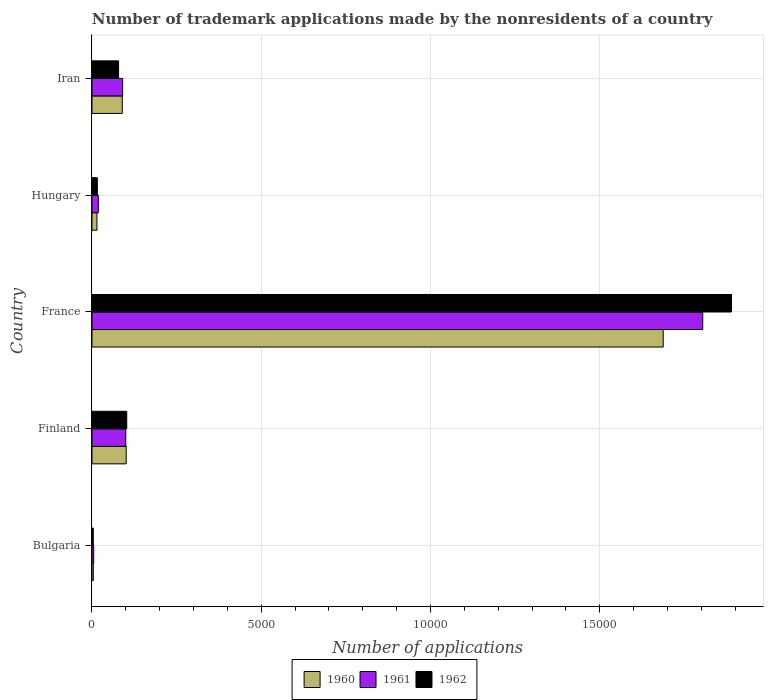How many different coloured bars are there?
Provide a succinct answer. 3. What is the label of the 1st group of bars from the top?
Ensure brevity in your answer.  Iran. In how many cases, is the number of bars for a given country not equal to the number of legend labels?
Give a very brief answer. 0. What is the number of trademark applications made by the nonresidents in 1961 in Finland?
Make the answer very short. 998. Across all countries, what is the maximum number of trademark applications made by the nonresidents in 1962?
Offer a very short reply. 1.89e+04. In which country was the number of trademark applications made by the nonresidents in 1960 maximum?
Make the answer very short. France. What is the total number of trademark applications made by the nonresidents in 1960 in the graph?
Your response must be concise. 1.90e+04. What is the difference between the number of trademark applications made by the nonresidents in 1960 in Hungary and that in Iran?
Your response must be concise. -748. What is the difference between the number of trademark applications made by the nonresidents in 1961 in Bulgaria and the number of trademark applications made by the nonresidents in 1960 in Iran?
Give a very brief answer. -844. What is the average number of trademark applications made by the nonresidents in 1962 per country?
Keep it short and to the point. 4180.2. What is the difference between the number of trademark applications made by the nonresidents in 1961 and number of trademark applications made by the nonresidents in 1960 in France?
Give a very brief answer. 1168. In how many countries, is the number of trademark applications made by the nonresidents in 1962 greater than 13000 ?
Give a very brief answer. 1. What is the ratio of the number of trademark applications made by the nonresidents in 1961 in Bulgaria to that in France?
Provide a succinct answer. 0. Is the difference between the number of trademark applications made by the nonresidents in 1961 in France and Hungary greater than the difference between the number of trademark applications made by the nonresidents in 1960 in France and Hungary?
Offer a very short reply. Yes. What is the difference between the highest and the second highest number of trademark applications made by the nonresidents in 1962?
Offer a very short reply. 1.79e+04. What is the difference between the highest and the lowest number of trademark applications made by the nonresidents in 1962?
Keep it short and to the point. 1.89e+04. Is the sum of the number of trademark applications made by the nonresidents in 1960 in Bulgaria and Iran greater than the maximum number of trademark applications made by the nonresidents in 1962 across all countries?
Make the answer very short. No. How many bars are there?
Give a very brief answer. 15. Are the values on the major ticks of X-axis written in scientific E-notation?
Give a very brief answer. No. Where does the legend appear in the graph?
Provide a short and direct response. Bottom center. How are the legend labels stacked?
Provide a short and direct response. Horizontal. What is the title of the graph?
Ensure brevity in your answer.  Number of trademark applications made by the nonresidents of a country. What is the label or title of the X-axis?
Keep it short and to the point. Number of applications. What is the label or title of the Y-axis?
Offer a terse response. Country. What is the Number of applications of 1961 in Bulgaria?
Offer a terse response. 51. What is the Number of applications in 1962 in Bulgaria?
Your answer should be compact. 38. What is the Number of applications of 1960 in Finland?
Your answer should be very brief. 1011. What is the Number of applications in 1961 in Finland?
Ensure brevity in your answer.  998. What is the Number of applications of 1962 in Finland?
Ensure brevity in your answer.  1027. What is the Number of applications of 1960 in France?
Make the answer very short. 1.69e+04. What is the Number of applications in 1961 in France?
Your answer should be compact. 1.80e+04. What is the Number of applications of 1962 in France?
Give a very brief answer. 1.89e+04. What is the Number of applications in 1960 in Hungary?
Make the answer very short. 147. What is the Number of applications in 1961 in Hungary?
Your answer should be compact. 188. What is the Number of applications of 1962 in Hungary?
Provide a succinct answer. 158. What is the Number of applications in 1960 in Iran?
Ensure brevity in your answer.  895. What is the Number of applications of 1961 in Iran?
Give a very brief answer. 905. What is the Number of applications in 1962 in Iran?
Provide a succinct answer. 786. Across all countries, what is the maximum Number of applications of 1960?
Your response must be concise. 1.69e+04. Across all countries, what is the maximum Number of applications of 1961?
Your answer should be very brief. 1.80e+04. Across all countries, what is the maximum Number of applications of 1962?
Make the answer very short. 1.89e+04. Across all countries, what is the minimum Number of applications of 1960?
Your answer should be compact. 39. Across all countries, what is the minimum Number of applications of 1962?
Provide a short and direct response. 38. What is the total Number of applications in 1960 in the graph?
Offer a terse response. 1.90e+04. What is the total Number of applications of 1961 in the graph?
Your answer should be compact. 2.02e+04. What is the total Number of applications of 1962 in the graph?
Offer a terse response. 2.09e+04. What is the difference between the Number of applications in 1960 in Bulgaria and that in Finland?
Your answer should be compact. -972. What is the difference between the Number of applications in 1961 in Bulgaria and that in Finland?
Ensure brevity in your answer.  -947. What is the difference between the Number of applications in 1962 in Bulgaria and that in Finland?
Keep it short and to the point. -989. What is the difference between the Number of applications of 1960 in Bulgaria and that in France?
Provide a succinct answer. -1.68e+04. What is the difference between the Number of applications of 1961 in Bulgaria and that in France?
Your response must be concise. -1.80e+04. What is the difference between the Number of applications of 1962 in Bulgaria and that in France?
Your answer should be compact. -1.89e+04. What is the difference between the Number of applications in 1960 in Bulgaria and that in Hungary?
Your response must be concise. -108. What is the difference between the Number of applications of 1961 in Bulgaria and that in Hungary?
Make the answer very short. -137. What is the difference between the Number of applications of 1962 in Bulgaria and that in Hungary?
Provide a short and direct response. -120. What is the difference between the Number of applications in 1960 in Bulgaria and that in Iran?
Give a very brief answer. -856. What is the difference between the Number of applications in 1961 in Bulgaria and that in Iran?
Your answer should be compact. -854. What is the difference between the Number of applications of 1962 in Bulgaria and that in Iran?
Offer a very short reply. -748. What is the difference between the Number of applications of 1960 in Finland and that in France?
Provide a succinct answer. -1.59e+04. What is the difference between the Number of applications in 1961 in Finland and that in France?
Offer a very short reply. -1.70e+04. What is the difference between the Number of applications of 1962 in Finland and that in France?
Keep it short and to the point. -1.79e+04. What is the difference between the Number of applications in 1960 in Finland and that in Hungary?
Make the answer very short. 864. What is the difference between the Number of applications of 1961 in Finland and that in Hungary?
Provide a succinct answer. 810. What is the difference between the Number of applications in 1962 in Finland and that in Hungary?
Ensure brevity in your answer.  869. What is the difference between the Number of applications of 1960 in Finland and that in Iran?
Ensure brevity in your answer.  116. What is the difference between the Number of applications in 1961 in Finland and that in Iran?
Provide a short and direct response. 93. What is the difference between the Number of applications in 1962 in Finland and that in Iran?
Offer a terse response. 241. What is the difference between the Number of applications in 1960 in France and that in Hungary?
Offer a very short reply. 1.67e+04. What is the difference between the Number of applications of 1961 in France and that in Hungary?
Provide a succinct answer. 1.79e+04. What is the difference between the Number of applications of 1962 in France and that in Hungary?
Your answer should be compact. 1.87e+04. What is the difference between the Number of applications in 1960 in France and that in Iran?
Ensure brevity in your answer.  1.60e+04. What is the difference between the Number of applications of 1961 in France and that in Iran?
Your answer should be compact. 1.71e+04. What is the difference between the Number of applications in 1962 in France and that in Iran?
Make the answer very short. 1.81e+04. What is the difference between the Number of applications in 1960 in Hungary and that in Iran?
Give a very brief answer. -748. What is the difference between the Number of applications of 1961 in Hungary and that in Iran?
Provide a short and direct response. -717. What is the difference between the Number of applications of 1962 in Hungary and that in Iran?
Your response must be concise. -628. What is the difference between the Number of applications of 1960 in Bulgaria and the Number of applications of 1961 in Finland?
Offer a very short reply. -959. What is the difference between the Number of applications in 1960 in Bulgaria and the Number of applications in 1962 in Finland?
Ensure brevity in your answer.  -988. What is the difference between the Number of applications in 1961 in Bulgaria and the Number of applications in 1962 in Finland?
Make the answer very short. -976. What is the difference between the Number of applications in 1960 in Bulgaria and the Number of applications in 1961 in France?
Provide a short and direct response. -1.80e+04. What is the difference between the Number of applications in 1960 in Bulgaria and the Number of applications in 1962 in France?
Make the answer very short. -1.89e+04. What is the difference between the Number of applications in 1961 in Bulgaria and the Number of applications in 1962 in France?
Offer a terse response. -1.88e+04. What is the difference between the Number of applications in 1960 in Bulgaria and the Number of applications in 1961 in Hungary?
Provide a succinct answer. -149. What is the difference between the Number of applications of 1960 in Bulgaria and the Number of applications of 1962 in Hungary?
Keep it short and to the point. -119. What is the difference between the Number of applications in 1961 in Bulgaria and the Number of applications in 1962 in Hungary?
Your response must be concise. -107. What is the difference between the Number of applications of 1960 in Bulgaria and the Number of applications of 1961 in Iran?
Offer a very short reply. -866. What is the difference between the Number of applications in 1960 in Bulgaria and the Number of applications in 1962 in Iran?
Ensure brevity in your answer.  -747. What is the difference between the Number of applications of 1961 in Bulgaria and the Number of applications of 1962 in Iran?
Your answer should be compact. -735. What is the difference between the Number of applications of 1960 in Finland and the Number of applications of 1961 in France?
Keep it short and to the point. -1.70e+04. What is the difference between the Number of applications in 1960 in Finland and the Number of applications in 1962 in France?
Make the answer very short. -1.79e+04. What is the difference between the Number of applications of 1961 in Finland and the Number of applications of 1962 in France?
Give a very brief answer. -1.79e+04. What is the difference between the Number of applications of 1960 in Finland and the Number of applications of 1961 in Hungary?
Offer a very short reply. 823. What is the difference between the Number of applications in 1960 in Finland and the Number of applications in 1962 in Hungary?
Give a very brief answer. 853. What is the difference between the Number of applications in 1961 in Finland and the Number of applications in 1962 in Hungary?
Your response must be concise. 840. What is the difference between the Number of applications in 1960 in Finland and the Number of applications in 1961 in Iran?
Your response must be concise. 106. What is the difference between the Number of applications of 1960 in Finland and the Number of applications of 1962 in Iran?
Your response must be concise. 225. What is the difference between the Number of applications of 1961 in Finland and the Number of applications of 1962 in Iran?
Ensure brevity in your answer.  212. What is the difference between the Number of applications in 1960 in France and the Number of applications in 1961 in Hungary?
Offer a very short reply. 1.67e+04. What is the difference between the Number of applications in 1960 in France and the Number of applications in 1962 in Hungary?
Give a very brief answer. 1.67e+04. What is the difference between the Number of applications in 1961 in France and the Number of applications in 1962 in Hungary?
Offer a terse response. 1.79e+04. What is the difference between the Number of applications of 1960 in France and the Number of applications of 1961 in Iran?
Make the answer very short. 1.60e+04. What is the difference between the Number of applications in 1960 in France and the Number of applications in 1962 in Iran?
Keep it short and to the point. 1.61e+04. What is the difference between the Number of applications in 1961 in France and the Number of applications in 1962 in Iran?
Provide a succinct answer. 1.73e+04. What is the difference between the Number of applications in 1960 in Hungary and the Number of applications in 1961 in Iran?
Keep it short and to the point. -758. What is the difference between the Number of applications of 1960 in Hungary and the Number of applications of 1962 in Iran?
Your response must be concise. -639. What is the difference between the Number of applications of 1961 in Hungary and the Number of applications of 1962 in Iran?
Your response must be concise. -598. What is the average Number of applications of 1960 per country?
Ensure brevity in your answer.  3793.2. What is the average Number of applications of 1961 per country?
Give a very brief answer. 4036.8. What is the average Number of applications of 1962 per country?
Provide a short and direct response. 4180.2. What is the difference between the Number of applications of 1960 and Number of applications of 1962 in Bulgaria?
Ensure brevity in your answer.  1. What is the difference between the Number of applications in 1960 and Number of applications in 1962 in Finland?
Provide a succinct answer. -16. What is the difference between the Number of applications of 1961 and Number of applications of 1962 in Finland?
Offer a terse response. -29. What is the difference between the Number of applications of 1960 and Number of applications of 1961 in France?
Ensure brevity in your answer.  -1168. What is the difference between the Number of applications in 1960 and Number of applications in 1962 in France?
Make the answer very short. -2018. What is the difference between the Number of applications of 1961 and Number of applications of 1962 in France?
Your response must be concise. -850. What is the difference between the Number of applications in 1960 and Number of applications in 1961 in Hungary?
Keep it short and to the point. -41. What is the difference between the Number of applications in 1960 and Number of applications in 1962 in Iran?
Ensure brevity in your answer.  109. What is the difference between the Number of applications in 1961 and Number of applications in 1962 in Iran?
Give a very brief answer. 119. What is the ratio of the Number of applications in 1960 in Bulgaria to that in Finland?
Your answer should be very brief. 0.04. What is the ratio of the Number of applications in 1961 in Bulgaria to that in Finland?
Offer a terse response. 0.05. What is the ratio of the Number of applications in 1962 in Bulgaria to that in Finland?
Make the answer very short. 0.04. What is the ratio of the Number of applications of 1960 in Bulgaria to that in France?
Give a very brief answer. 0. What is the ratio of the Number of applications in 1961 in Bulgaria to that in France?
Provide a succinct answer. 0. What is the ratio of the Number of applications of 1962 in Bulgaria to that in France?
Keep it short and to the point. 0. What is the ratio of the Number of applications in 1960 in Bulgaria to that in Hungary?
Offer a terse response. 0.27. What is the ratio of the Number of applications in 1961 in Bulgaria to that in Hungary?
Your answer should be compact. 0.27. What is the ratio of the Number of applications of 1962 in Bulgaria to that in Hungary?
Ensure brevity in your answer.  0.24. What is the ratio of the Number of applications of 1960 in Bulgaria to that in Iran?
Make the answer very short. 0.04. What is the ratio of the Number of applications of 1961 in Bulgaria to that in Iran?
Give a very brief answer. 0.06. What is the ratio of the Number of applications of 1962 in Bulgaria to that in Iran?
Keep it short and to the point. 0.05. What is the ratio of the Number of applications of 1960 in Finland to that in France?
Provide a succinct answer. 0.06. What is the ratio of the Number of applications of 1961 in Finland to that in France?
Keep it short and to the point. 0.06. What is the ratio of the Number of applications of 1962 in Finland to that in France?
Make the answer very short. 0.05. What is the ratio of the Number of applications in 1960 in Finland to that in Hungary?
Your response must be concise. 6.88. What is the ratio of the Number of applications in 1961 in Finland to that in Hungary?
Provide a succinct answer. 5.31. What is the ratio of the Number of applications in 1962 in Finland to that in Hungary?
Ensure brevity in your answer.  6.5. What is the ratio of the Number of applications in 1960 in Finland to that in Iran?
Give a very brief answer. 1.13. What is the ratio of the Number of applications in 1961 in Finland to that in Iran?
Keep it short and to the point. 1.1. What is the ratio of the Number of applications of 1962 in Finland to that in Iran?
Offer a terse response. 1.31. What is the ratio of the Number of applications of 1960 in France to that in Hungary?
Your response must be concise. 114.79. What is the ratio of the Number of applications of 1961 in France to that in Hungary?
Provide a succinct answer. 95.97. What is the ratio of the Number of applications in 1962 in France to that in Hungary?
Offer a very short reply. 119.57. What is the ratio of the Number of applications in 1960 in France to that in Iran?
Keep it short and to the point. 18.85. What is the ratio of the Number of applications in 1961 in France to that in Iran?
Offer a terse response. 19.94. What is the ratio of the Number of applications in 1962 in France to that in Iran?
Ensure brevity in your answer.  24.04. What is the ratio of the Number of applications of 1960 in Hungary to that in Iran?
Offer a terse response. 0.16. What is the ratio of the Number of applications in 1961 in Hungary to that in Iran?
Keep it short and to the point. 0.21. What is the ratio of the Number of applications of 1962 in Hungary to that in Iran?
Your answer should be compact. 0.2. What is the difference between the highest and the second highest Number of applications in 1960?
Offer a very short reply. 1.59e+04. What is the difference between the highest and the second highest Number of applications of 1961?
Provide a succinct answer. 1.70e+04. What is the difference between the highest and the second highest Number of applications in 1962?
Make the answer very short. 1.79e+04. What is the difference between the highest and the lowest Number of applications in 1960?
Your response must be concise. 1.68e+04. What is the difference between the highest and the lowest Number of applications of 1961?
Your answer should be very brief. 1.80e+04. What is the difference between the highest and the lowest Number of applications in 1962?
Provide a succinct answer. 1.89e+04. 